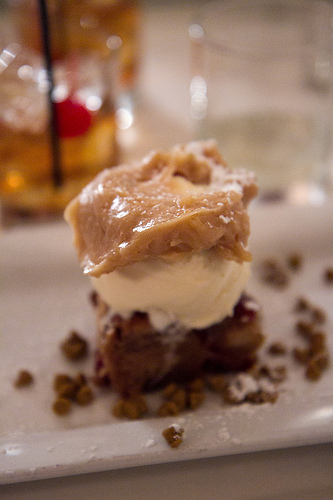<image>
Is the ice cream in front of the cup? Yes. The ice cream is positioned in front of the cup, appearing closer to the camera viewpoint. 